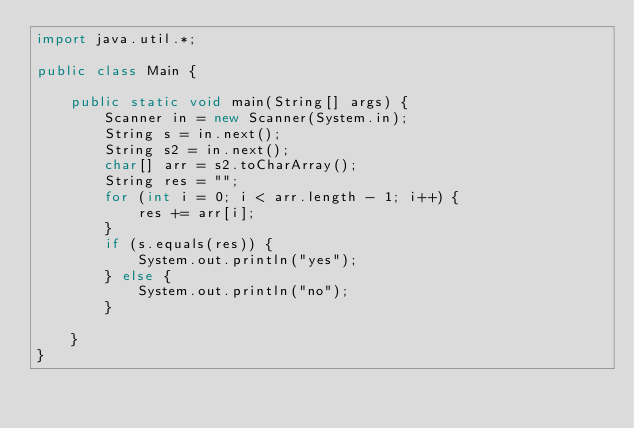Convert code to text. <code><loc_0><loc_0><loc_500><loc_500><_Java_>import java.util.*;

public class Main {

    public static void main(String[] args) {
        Scanner in = new Scanner(System.in);
        String s = in.next();
        String s2 = in.next();
        char[] arr = s2.toCharArray();
        String res = "";
        for (int i = 0; i < arr.length - 1; i++) {
            res += arr[i];
        }
        if (s.equals(res)) {
            System.out.println("yes");
        } else {
            System.out.println("no");
        }

    }
}</code> 